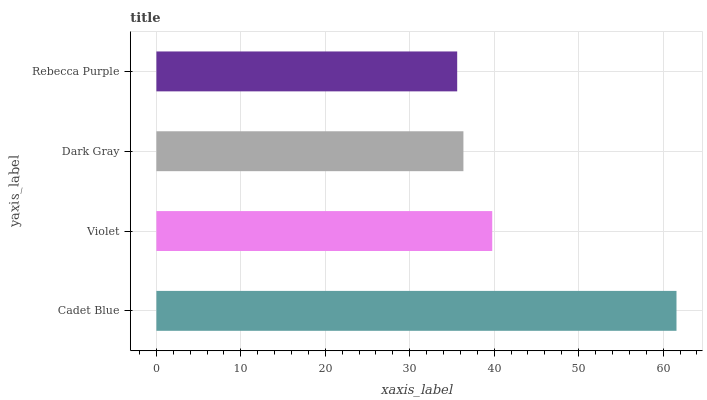Is Rebecca Purple the minimum?
Answer yes or no. Yes. Is Cadet Blue the maximum?
Answer yes or no. Yes. Is Violet the minimum?
Answer yes or no. No. Is Violet the maximum?
Answer yes or no. No. Is Cadet Blue greater than Violet?
Answer yes or no. Yes. Is Violet less than Cadet Blue?
Answer yes or no. Yes. Is Violet greater than Cadet Blue?
Answer yes or no. No. Is Cadet Blue less than Violet?
Answer yes or no. No. Is Violet the high median?
Answer yes or no. Yes. Is Dark Gray the low median?
Answer yes or no. Yes. Is Rebecca Purple the high median?
Answer yes or no. No. Is Cadet Blue the low median?
Answer yes or no. No. 